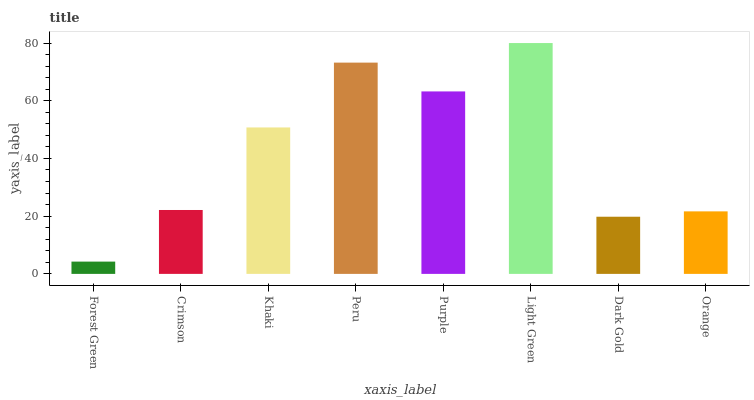Is Forest Green the minimum?
Answer yes or no. Yes. Is Light Green the maximum?
Answer yes or no. Yes. Is Crimson the minimum?
Answer yes or no. No. Is Crimson the maximum?
Answer yes or no. No. Is Crimson greater than Forest Green?
Answer yes or no. Yes. Is Forest Green less than Crimson?
Answer yes or no. Yes. Is Forest Green greater than Crimson?
Answer yes or no. No. Is Crimson less than Forest Green?
Answer yes or no. No. Is Khaki the high median?
Answer yes or no. Yes. Is Crimson the low median?
Answer yes or no. Yes. Is Peru the high median?
Answer yes or no. No. Is Peru the low median?
Answer yes or no. No. 